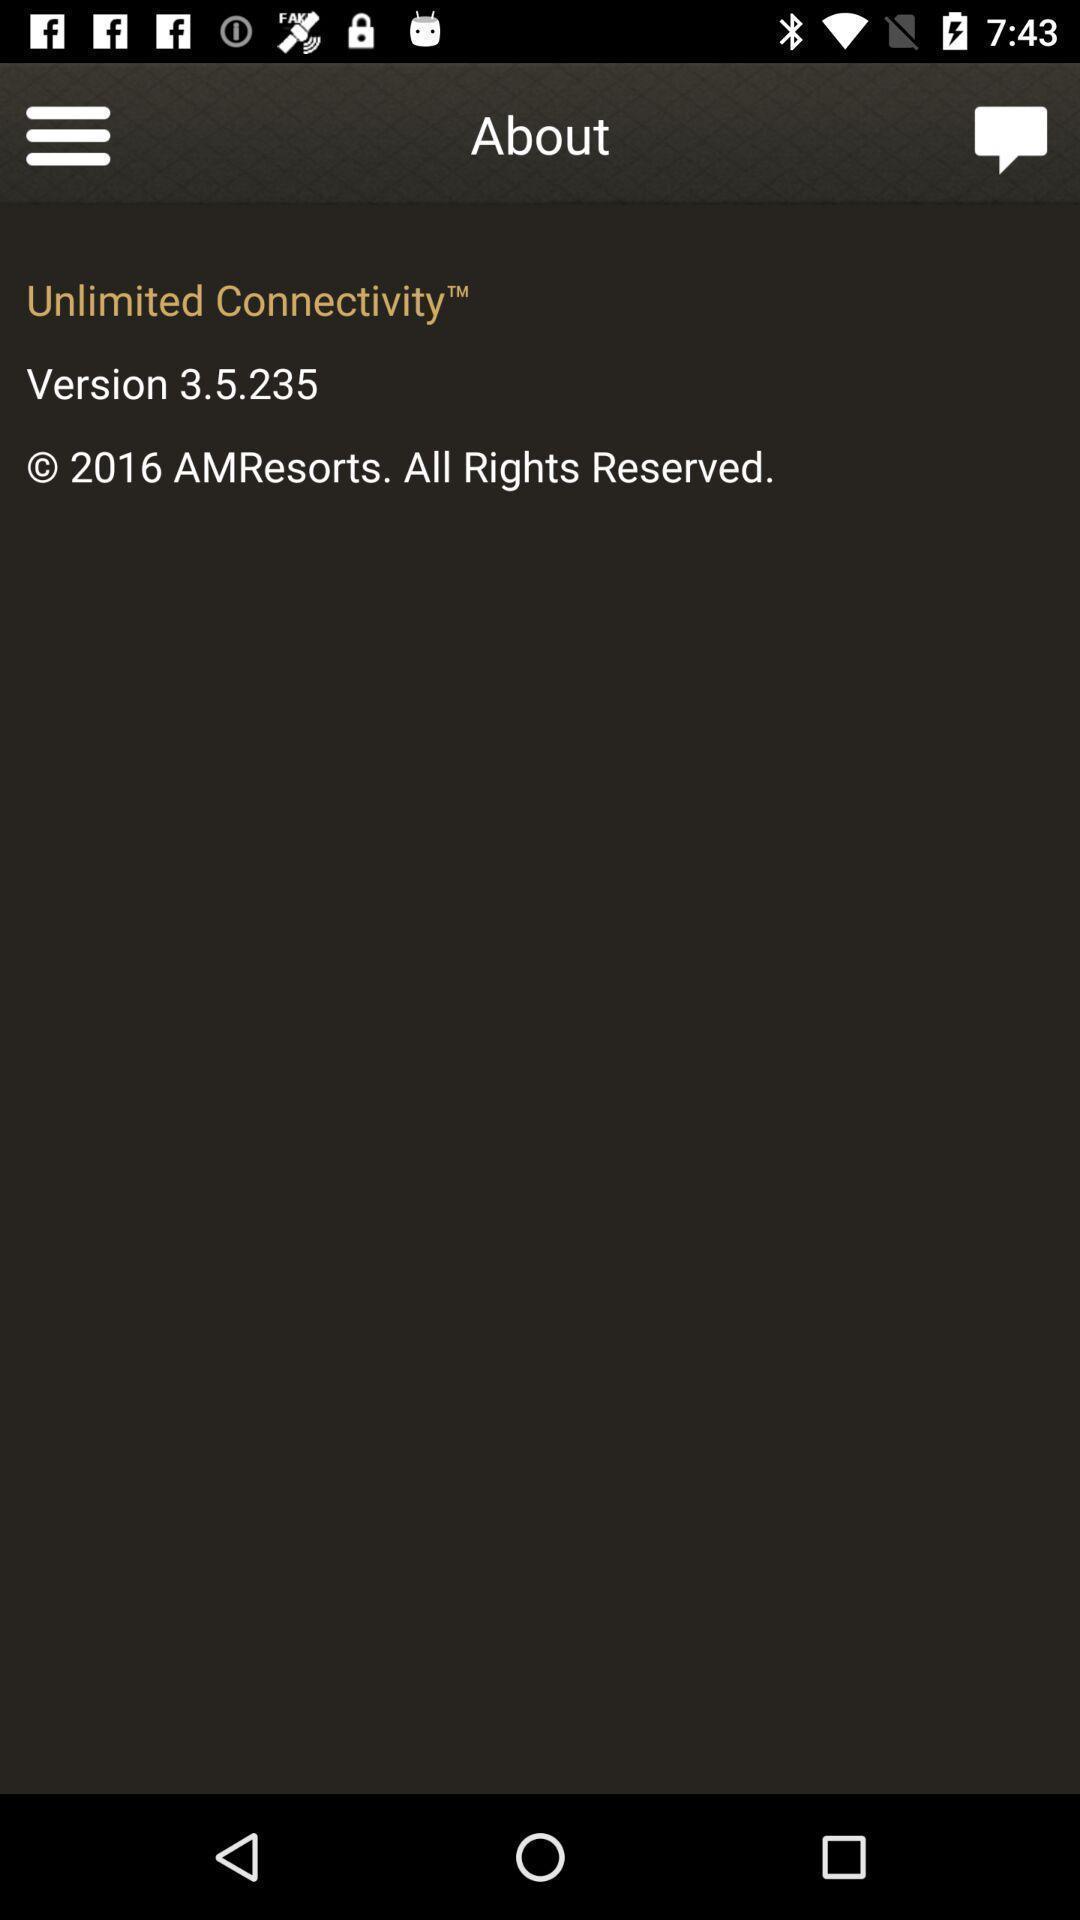Describe the content in this image. Screen showing about. 